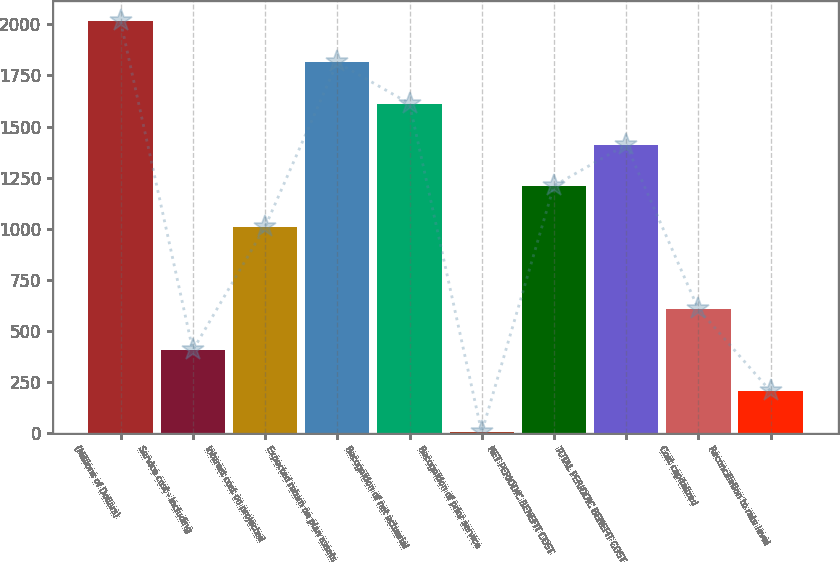Convert chart to OTSL. <chart><loc_0><loc_0><loc_500><loc_500><bar_chart><fcel>(Millions of Dollars)<fcel>Service cost - including<fcel>Interest cost on projected<fcel>Expected return on plan assets<fcel>Recognition of net actuarial<fcel>Recognition of prior service<fcel>NET PERIODIC BENEFIT COST<fcel>TOTAL PERIODIC BENEFIT COST<fcel>Cost capitalized<fcel>Reconciliation to rate level<nl><fcel>2015<fcel>404.6<fcel>1008.5<fcel>1813.7<fcel>1612.4<fcel>2<fcel>1209.8<fcel>1411.1<fcel>605.9<fcel>203.3<nl></chart> 